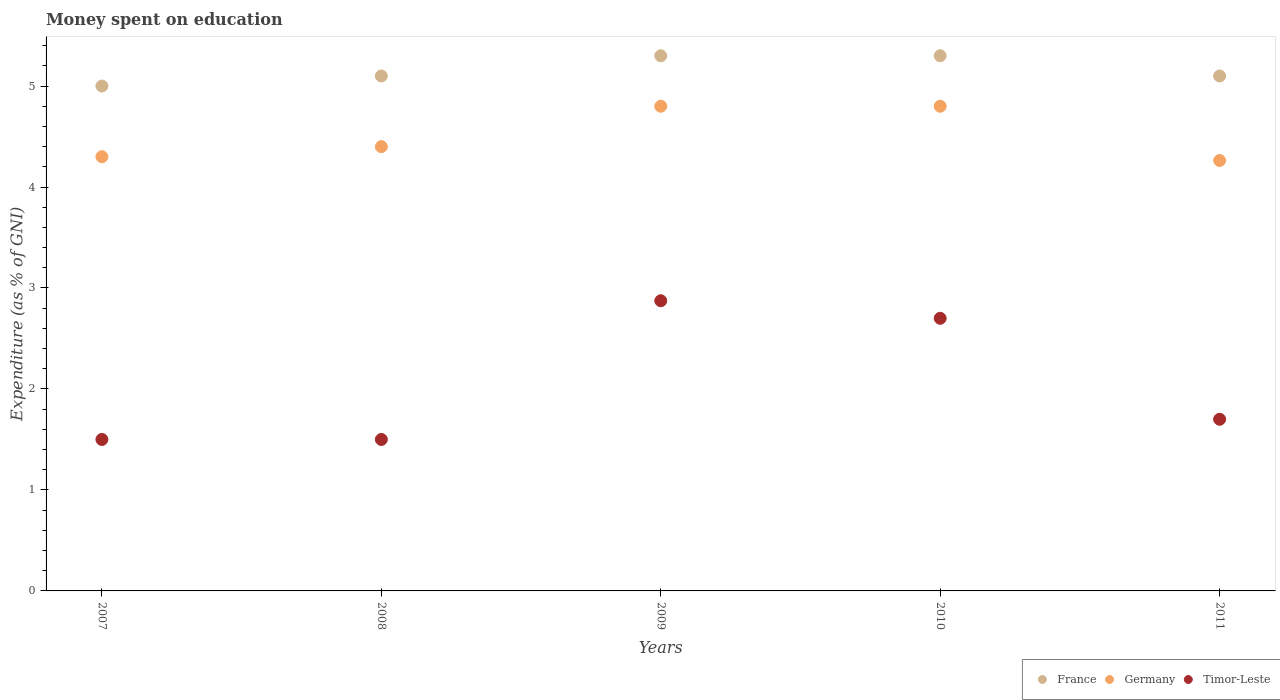How many different coloured dotlines are there?
Your answer should be compact. 3. Is the number of dotlines equal to the number of legend labels?
Provide a short and direct response. Yes. What is the amount of money spent on education in Timor-Leste in 2011?
Offer a terse response. 1.7. Across all years, what is the minimum amount of money spent on education in Timor-Leste?
Offer a very short reply. 1.5. In which year was the amount of money spent on education in Germany minimum?
Your answer should be very brief. 2011. What is the total amount of money spent on education in France in the graph?
Your answer should be compact. 25.8. What is the difference between the amount of money spent on education in Germany in 2008 and the amount of money spent on education in Timor-Leste in 2009?
Make the answer very short. 1.53. What is the average amount of money spent on education in France per year?
Your answer should be compact. 5.16. In the year 2011, what is the difference between the amount of money spent on education in Timor-Leste and amount of money spent on education in France?
Offer a terse response. -3.4. What is the ratio of the amount of money spent on education in Timor-Leste in 2008 to that in 2011?
Provide a short and direct response. 0.88. Is the amount of money spent on education in France in 2007 less than that in 2008?
Ensure brevity in your answer.  Yes. Is the difference between the amount of money spent on education in Timor-Leste in 2007 and 2010 greater than the difference between the amount of money spent on education in France in 2007 and 2010?
Keep it short and to the point. No. What is the difference between the highest and the second highest amount of money spent on education in France?
Offer a very short reply. 0. What is the difference between the highest and the lowest amount of money spent on education in Germany?
Provide a succinct answer. 0.54. Is it the case that in every year, the sum of the amount of money spent on education in Germany and amount of money spent on education in France  is greater than the amount of money spent on education in Timor-Leste?
Keep it short and to the point. Yes. Is the amount of money spent on education in Germany strictly greater than the amount of money spent on education in France over the years?
Offer a very short reply. No. How many years are there in the graph?
Provide a short and direct response. 5. Are the values on the major ticks of Y-axis written in scientific E-notation?
Provide a succinct answer. No. Does the graph contain any zero values?
Provide a short and direct response. No. Where does the legend appear in the graph?
Ensure brevity in your answer.  Bottom right. What is the title of the graph?
Offer a very short reply. Money spent on education. Does "Sweden" appear as one of the legend labels in the graph?
Ensure brevity in your answer.  No. What is the label or title of the Y-axis?
Keep it short and to the point. Expenditure (as % of GNI). What is the Expenditure (as % of GNI) of Germany in 2007?
Your answer should be compact. 4.3. What is the Expenditure (as % of GNI) of France in 2008?
Provide a short and direct response. 5.1. What is the Expenditure (as % of GNI) of Germany in 2008?
Offer a terse response. 4.4. What is the Expenditure (as % of GNI) of France in 2009?
Provide a short and direct response. 5.3. What is the Expenditure (as % of GNI) in Germany in 2009?
Keep it short and to the point. 4.8. What is the Expenditure (as % of GNI) of Timor-Leste in 2009?
Provide a succinct answer. 2.87. What is the Expenditure (as % of GNI) in France in 2011?
Offer a terse response. 5.1. What is the Expenditure (as % of GNI) of Germany in 2011?
Give a very brief answer. 4.26. What is the Expenditure (as % of GNI) in Timor-Leste in 2011?
Your answer should be compact. 1.7. Across all years, what is the maximum Expenditure (as % of GNI) in France?
Your answer should be very brief. 5.3. Across all years, what is the maximum Expenditure (as % of GNI) of Timor-Leste?
Provide a succinct answer. 2.87. Across all years, what is the minimum Expenditure (as % of GNI) in France?
Make the answer very short. 5. Across all years, what is the minimum Expenditure (as % of GNI) in Germany?
Make the answer very short. 4.26. What is the total Expenditure (as % of GNI) in France in the graph?
Provide a succinct answer. 25.8. What is the total Expenditure (as % of GNI) of Germany in the graph?
Offer a terse response. 22.56. What is the total Expenditure (as % of GNI) in Timor-Leste in the graph?
Keep it short and to the point. 10.27. What is the difference between the Expenditure (as % of GNI) of Germany in 2007 and that in 2008?
Your answer should be compact. -0.1. What is the difference between the Expenditure (as % of GNI) in Timor-Leste in 2007 and that in 2009?
Give a very brief answer. -1.37. What is the difference between the Expenditure (as % of GNI) of France in 2007 and that in 2011?
Offer a very short reply. -0.1. What is the difference between the Expenditure (as % of GNI) of Germany in 2007 and that in 2011?
Provide a succinct answer. 0.04. What is the difference between the Expenditure (as % of GNI) of France in 2008 and that in 2009?
Give a very brief answer. -0.2. What is the difference between the Expenditure (as % of GNI) in Germany in 2008 and that in 2009?
Your response must be concise. -0.4. What is the difference between the Expenditure (as % of GNI) in Timor-Leste in 2008 and that in 2009?
Your response must be concise. -1.37. What is the difference between the Expenditure (as % of GNI) of Timor-Leste in 2008 and that in 2010?
Your answer should be compact. -1.2. What is the difference between the Expenditure (as % of GNI) in Germany in 2008 and that in 2011?
Offer a terse response. 0.14. What is the difference between the Expenditure (as % of GNI) in Timor-Leste in 2008 and that in 2011?
Your answer should be compact. -0.2. What is the difference between the Expenditure (as % of GNI) of Germany in 2009 and that in 2010?
Offer a very short reply. 0. What is the difference between the Expenditure (as % of GNI) in Timor-Leste in 2009 and that in 2010?
Ensure brevity in your answer.  0.17. What is the difference between the Expenditure (as % of GNI) in France in 2009 and that in 2011?
Provide a short and direct response. 0.2. What is the difference between the Expenditure (as % of GNI) of Germany in 2009 and that in 2011?
Your answer should be very brief. 0.54. What is the difference between the Expenditure (as % of GNI) in Timor-Leste in 2009 and that in 2011?
Your answer should be compact. 1.17. What is the difference between the Expenditure (as % of GNI) in France in 2010 and that in 2011?
Offer a very short reply. 0.2. What is the difference between the Expenditure (as % of GNI) in Germany in 2010 and that in 2011?
Your response must be concise. 0.54. What is the difference between the Expenditure (as % of GNI) of France in 2007 and the Expenditure (as % of GNI) of Timor-Leste in 2008?
Offer a terse response. 3.5. What is the difference between the Expenditure (as % of GNI) of Germany in 2007 and the Expenditure (as % of GNI) of Timor-Leste in 2008?
Ensure brevity in your answer.  2.8. What is the difference between the Expenditure (as % of GNI) of France in 2007 and the Expenditure (as % of GNI) of Timor-Leste in 2009?
Make the answer very short. 2.13. What is the difference between the Expenditure (as % of GNI) of Germany in 2007 and the Expenditure (as % of GNI) of Timor-Leste in 2009?
Make the answer very short. 1.43. What is the difference between the Expenditure (as % of GNI) of France in 2007 and the Expenditure (as % of GNI) of Germany in 2010?
Provide a succinct answer. 0.2. What is the difference between the Expenditure (as % of GNI) of France in 2007 and the Expenditure (as % of GNI) of Timor-Leste in 2010?
Make the answer very short. 2.3. What is the difference between the Expenditure (as % of GNI) of France in 2007 and the Expenditure (as % of GNI) of Germany in 2011?
Ensure brevity in your answer.  0.74. What is the difference between the Expenditure (as % of GNI) of France in 2008 and the Expenditure (as % of GNI) of Timor-Leste in 2009?
Provide a short and direct response. 2.23. What is the difference between the Expenditure (as % of GNI) in Germany in 2008 and the Expenditure (as % of GNI) in Timor-Leste in 2009?
Keep it short and to the point. 1.53. What is the difference between the Expenditure (as % of GNI) of France in 2008 and the Expenditure (as % of GNI) of Germany in 2010?
Make the answer very short. 0.3. What is the difference between the Expenditure (as % of GNI) of Germany in 2008 and the Expenditure (as % of GNI) of Timor-Leste in 2010?
Keep it short and to the point. 1.7. What is the difference between the Expenditure (as % of GNI) in France in 2008 and the Expenditure (as % of GNI) in Germany in 2011?
Your answer should be very brief. 0.84. What is the difference between the Expenditure (as % of GNI) in France in 2008 and the Expenditure (as % of GNI) in Timor-Leste in 2011?
Your answer should be very brief. 3.4. What is the difference between the Expenditure (as % of GNI) of Germany in 2008 and the Expenditure (as % of GNI) of Timor-Leste in 2011?
Provide a short and direct response. 2.7. What is the difference between the Expenditure (as % of GNI) of France in 2009 and the Expenditure (as % of GNI) of Germany in 2011?
Keep it short and to the point. 1.04. What is the difference between the Expenditure (as % of GNI) of Germany in 2009 and the Expenditure (as % of GNI) of Timor-Leste in 2011?
Your response must be concise. 3.1. What is the difference between the Expenditure (as % of GNI) of France in 2010 and the Expenditure (as % of GNI) of Germany in 2011?
Offer a very short reply. 1.04. What is the difference between the Expenditure (as % of GNI) of France in 2010 and the Expenditure (as % of GNI) of Timor-Leste in 2011?
Offer a terse response. 3.6. What is the difference between the Expenditure (as % of GNI) in Germany in 2010 and the Expenditure (as % of GNI) in Timor-Leste in 2011?
Make the answer very short. 3.1. What is the average Expenditure (as % of GNI) in France per year?
Ensure brevity in your answer.  5.16. What is the average Expenditure (as % of GNI) of Germany per year?
Keep it short and to the point. 4.51. What is the average Expenditure (as % of GNI) of Timor-Leste per year?
Make the answer very short. 2.05. In the year 2008, what is the difference between the Expenditure (as % of GNI) in Germany and Expenditure (as % of GNI) in Timor-Leste?
Offer a very short reply. 2.9. In the year 2009, what is the difference between the Expenditure (as % of GNI) of France and Expenditure (as % of GNI) of Germany?
Make the answer very short. 0.5. In the year 2009, what is the difference between the Expenditure (as % of GNI) in France and Expenditure (as % of GNI) in Timor-Leste?
Provide a short and direct response. 2.43. In the year 2009, what is the difference between the Expenditure (as % of GNI) in Germany and Expenditure (as % of GNI) in Timor-Leste?
Provide a succinct answer. 1.93. In the year 2011, what is the difference between the Expenditure (as % of GNI) of France and Expenditure (as % of GNI) of Germany?
Your answer should be very brief. 0.84. In the year 2011, what is the difference between the Expenditure (as % of GNI) in France and Expenditure (as % of GNI) in Timor-Leste?
Offer a very short reply. 3.4. In the year 2011, what is the difference between the Expenditure (as % of GNI) of Germany and Expenditure (as % of GNI) of Timor-Leste?
Make the answer very short. 2.56. What is the ratio of the Expenditure (as % of GNI) in France in 2007 to that in 2008?
Your answer should be compact. 0.98. What is the ratio of the Expenditure (as % of GNI) in Germany in 2007 to that in 2008?
Provide a succinct answer. 0.98. What is the ratio of the Expenditure (as % of GNI) of Timor-Leste in 2007 to that in 2008?
Make the answer very short. 1. What is the ratio of the Expenditure (as % of GNI) of France in 2007 to that in 2009?
Provide a succinct answer. 0.94. What is the ratio of the Expenditure (as % of GNI) of Germany in 2007 to that in 2009?
Make the answer very short. 0.9. What is the ratio of the Expenditure (as % of GNI) in Timor-Leste in 2007 to that in 2009?
Your answer should be very brief. 0.52. What is the ratio of the Expenditure (as % of GNI) in France in 2007 to that in 2010?
Provide a short and direct response. 0.94. What is the ratio of the Expenditure (as % of GNI) of Germany in 2007 to that in 2010?
Provide a short and direct response. 0.9. What is the ratio of the Expenditure (as % of GNI) of Timor-Leste in 2007 to that in 2010?
Provide a short and direct response. 0.56. What is the ratio of the Expenditure (as % of GNI) of France in 2007 to that in 2011?
Provide a short and direct response. 0.98. What is the ratio of the Expenditure (as % of GNI) of Germany in 2007 to that in 2011?
Your answer should be compact. 1.01. What is the ratio of the Expenditure (as % of GNI) in Timor-Leste in 2007 to that in 2011?
Provide a succinct answer. 0.88. What is the ratio of the Expenditure (as % of GNI) of France in 2008 to that in 2009?
Give a very brief answer. 0.96. What is the ratio of the Expenditure (as % of GNI) in Timor-Leste in 2008 to that in 2009?
Give a very brief answer. 0.52. What is the ratio of the Expenditure (as % of GNI) in France in 2008 to that in 2010?
Your answer should be compact. 0.96. What is the ratio of the Expenditure (as % of GNI) in Timor-Leste in 2008 to that in 2010?
Your answer should be compact. 0.56. What is the ratio of the Expenditure (as % of GNI) of France in 2008 to that in 2011?
Your answer should be very brief. 1. What is the ratio of the Expenditure (as % of GNI) of Germany in 2008 to that in 2011?
Your answer should be compact. 1.03. What is the ratio of the Expenditure (as % of GNI) of Timor-Leste in 2008 to that in 2011?
Provide a short and direct response. 0.88. What is the ratio of the Expenditure (as % of GNI) of France in 2009 to that in 2010?
Make the answer very short. 1. What is the ratio of the Expenditure (as % of GNI) in Timor-Leste in 2009 to that in 2010?
Give a very brief answer. 1.06. What is the ratio of the Expenditure (as % of GNI) of France in 2009 to that in 2011?
Your answer should be compact. 1.04. What is the ratio of the Expenditure (as % of GNI) of Germany in 2009 to that in 2011?
Your answer should be compact. 1.13. What is the ratio of the Expenditure (as % of GNI) in Timor-Leste in 2009 to that in 2011?
Provide a short and direct response. 1.69. What is the ratio of the Expenditure (as % of GNI) in France in 2010 to that in 2011?
Provide a succinct answer. 1.04. What is the ratio of the Expenditure (as % of GNI) in Germany in 2010 to that in 2011?
Your answer should be very brief. 1.13. What is the ratio of the Expenditure (as % of GNI) of Timor-Leste in 2010 to that in 2011?
Offer a terse response. 1.59. What is the difference between the highest and the second highest Expenditure (as % of GNI) of France?
Make the answer very short. 0. What is the difference between the highest and the second highest Expenditure (as % of GNI) of Timor-Leste?
Your answer should be very brief. 0.17. What is the difference between the highest and the lowest Expenditure (as % of GNI) of France?
Provide a short and direct response. 0.3. What is the difference between the highest and the lowest Expenditure (as % of GNI) in Germany?
Make the answer very short. 0.54. What is the difference between the highest and the lowest Expenditure (as % of GNI) of Timor-Leste?
Ensure brevity in your answer.  1.37. 